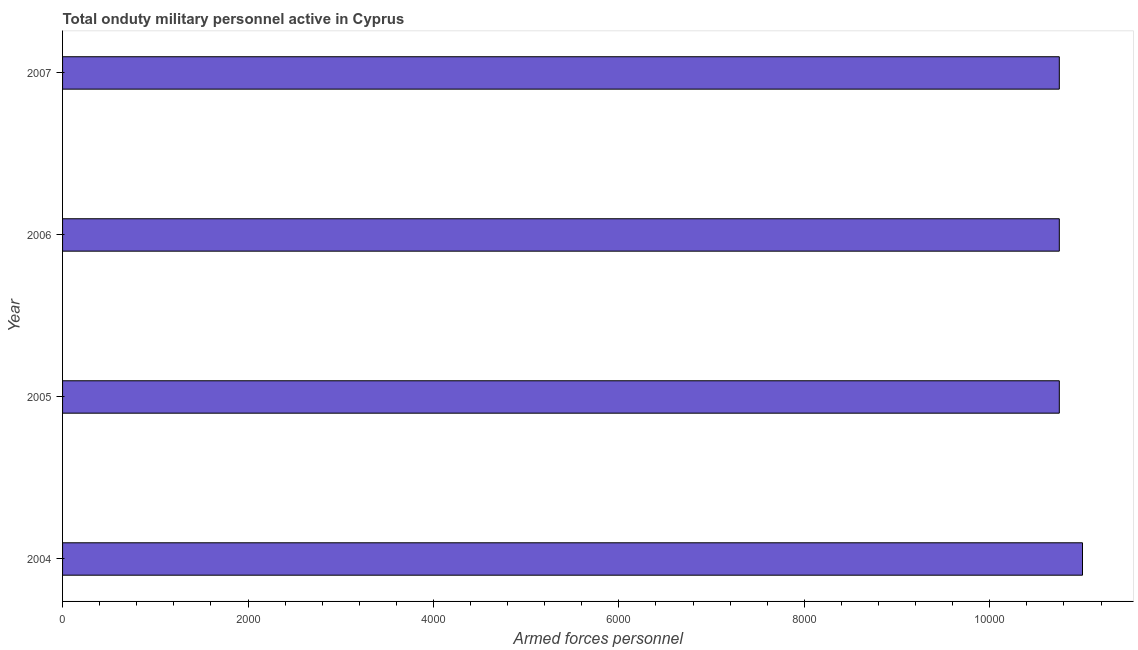Does the graph contain any zero values?
Offer a very short reply. No. What is the title of the graph?
Your response must be concise. Total onduty military personnel active in Cyprus. What is the label or title of the X-axis?
Offer a very short reply. Armed forces personnel. What is the number of armed forces personnel in 2007?
Keep it short and to the point. 1.08e+04. Across all years, what is the maximum number of armed forces personnel?
Offer a very short reply. 1.10e+04. Across all years, what is the minimum number of armed forces personnel?
Your answer should be compact. 1.08e+04. In which year was the number of armed forces personnel minimum?
Your answer should be compact. 2005. What is the sum of the number of armed forces personnel?
Keep it short and to the point. 4.32e+04. What is the difference between the number of armed forces personnel in 2004 and 2007?
Your answer should be compact. 250. What is the average number of armed forces personnel per year?
Ensure brevity in your answer.  1.08e+04. What is the median number of armed forces personnel?
Ensure brevity in your answer.  1.08e+04. In how many years, is the number of armed forces personnel greater than 8400 ?
Your response must be concise. 4. Do a majority of the years between 2006 and 2004 (inclusive) have number of armed forces personnel greater than 4400 ?
Give a very brief answer. Yes. What is the ratio of the number of armed forces personnel in 2004 to that in 2007?
Your answer should be very brief. 1.02. Is the difference between the number of armed forces personnel in 2004 and 2005 greater than the difference between any two years?
Your answer should be very brief. Yes. What is the difference between the highest and the second highest number of armed forces personnel?
Give a very brief answer. 250. Is the sum of the number of armed forces personnel in 2004 and 2005 greater than the maximum number of armed forces personnel across all years?
Your answer should be very brief. Yes. What is the difference between the highest and the lowest number of armed forces personnel?
Your answer should be compact. 250. How many bars are there?
Your answer should be very brief. 4. Are all the bars in the graph horizontal?
Provide a short and direct response. Yes. How many years are there in the graph?
Your response must be concise. 4. What is the difference between two consecutive major ticks on the X-axis?
Keep it short and to the point. 2000. Are the values on the major ticks of X-axis written in scientific E-notation?
Your response must be concise. No. What is the Armed forces personnel in 2004?
Offer a terse response. 1.10e+04. What is the Armed forces personnel in 2005?
Offer a terse response. 1.08e+04. What is the Armed forces personnel of 2006?
Give a very brief answer. 1.08e+04. What is the Armed forces personnel of 2007?
Provide a succinct answer. 1.08e+04. What is the difference between the Armed forces personnel in 2004 and 2005?
Make the answer very short. 250. What is the difference between the Armed forces personnel in 2004 and 2006?
Make the answer very short. 250. What is the difference between the Armed forces personnel in 2004 and 2007?
Keep it short and to the point. 250. What is the difference between the Armed forces personnel in 2005 and 2006?
Provide a short and direct response. 0. What is the difference between the Armed forces personnel in 2005 and 2007?
Your answer should be compact. 0. What is the ratio of the Armed forces personnel in 2004 to that in 2007?
Make the answer very short. 1.02. What is the ratio of the Armed forces personnel in 2005 to that in 2006?
Keep it short and to the point. 1. What is the ratio of the Armed forces personnel in 2005 to that in 2007?
Your response must be concise. 1. What is the ratio of the Armed forces personnel in 2006 to that in 2007?
Ensure brevity in your answer.  1. 